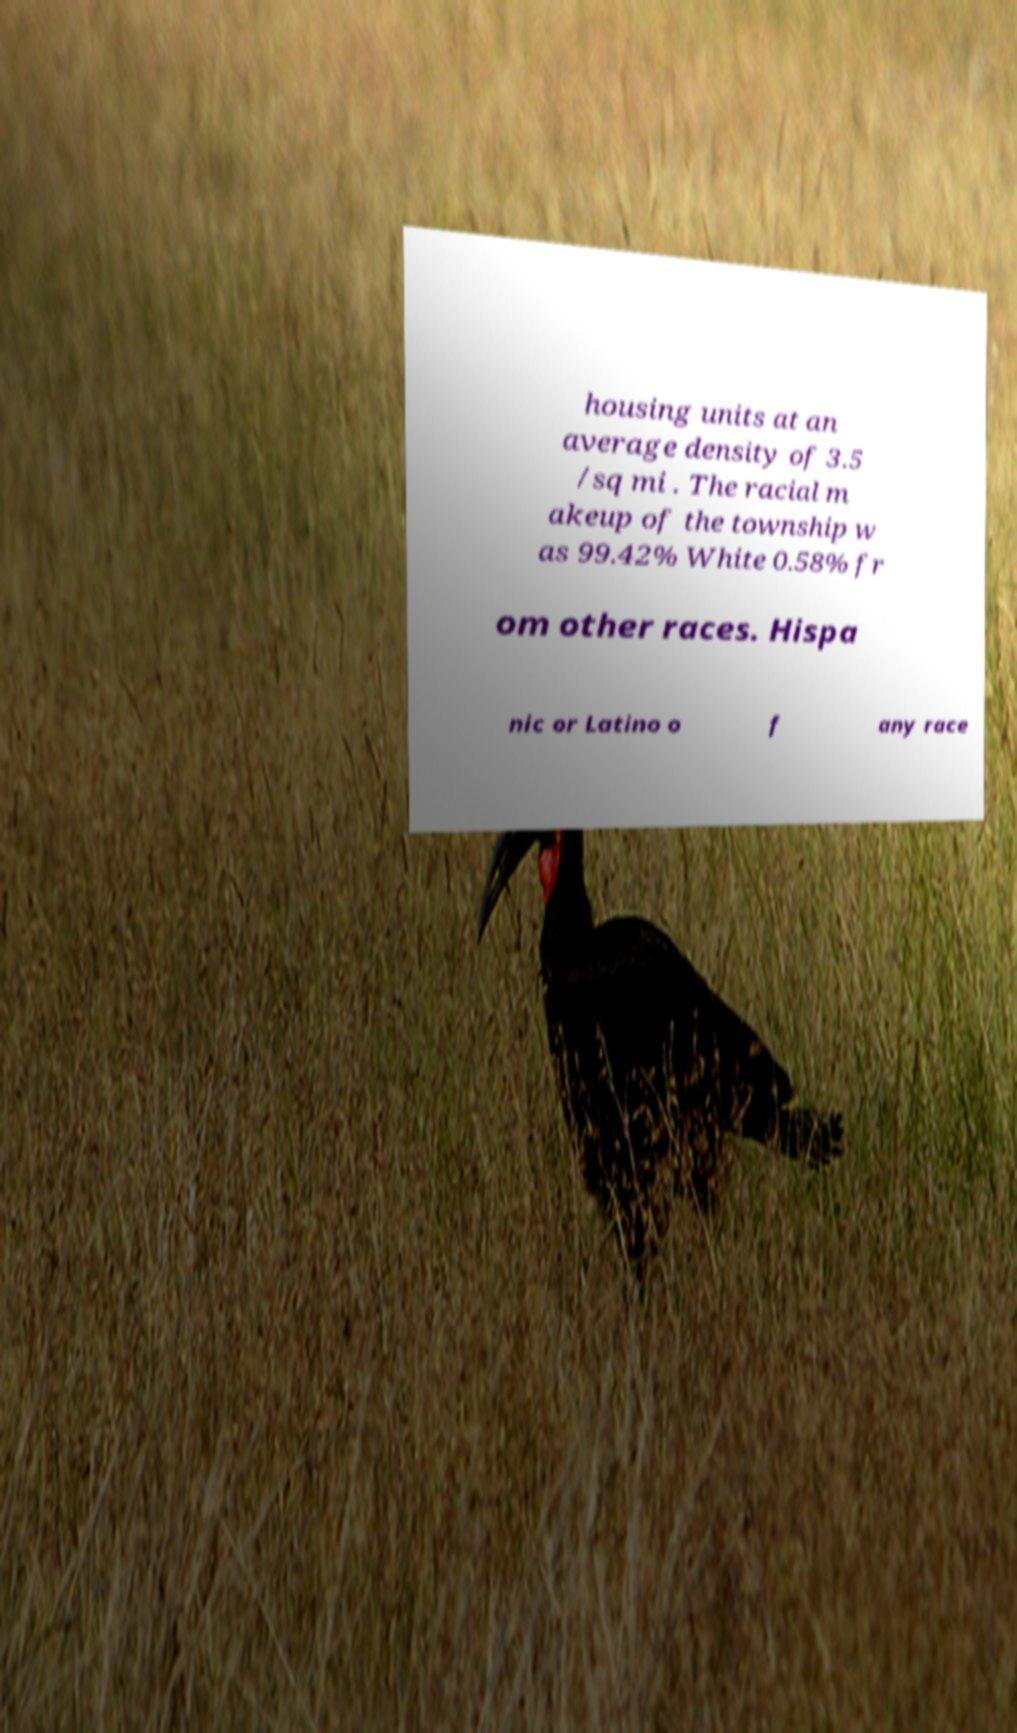Can you accurately transcribe the text from the provided image for me? housing units at an average density of 3.5 /sq mi . The racial m akeup of the township w as 99.42% White 0.58% fr om other races. Hispa nic or Latino o f any race 